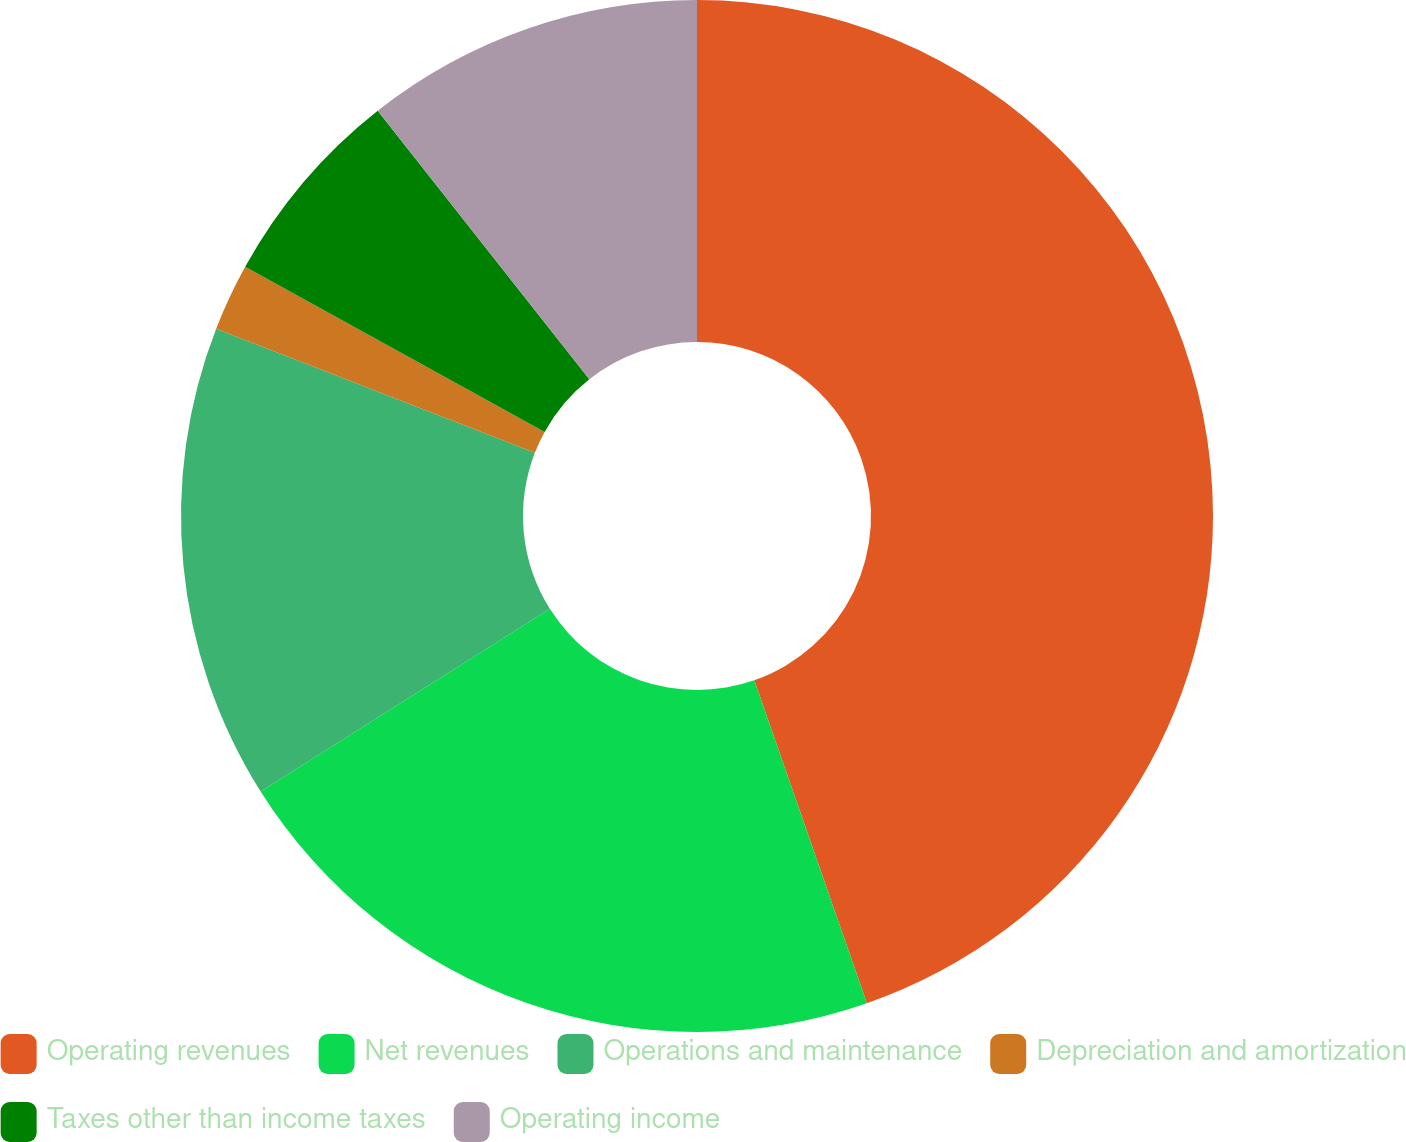Convert chart to OTSL. <chart><loc_0><loc_0><loc_500><loc_500><pie_chart><fcel>Operating revenues<fcel>Net revenues<fcel>Operations and maintenance<fcel>Depreciation and amortization<fcel>Taxes other than income taxes<fcel>Operating income<nl><fcel>44.66%<fcel>21.38%<fcel>14.87%<fcel>2.11%<fcel>6.36%<fcel>10.62%<nl></chart> 